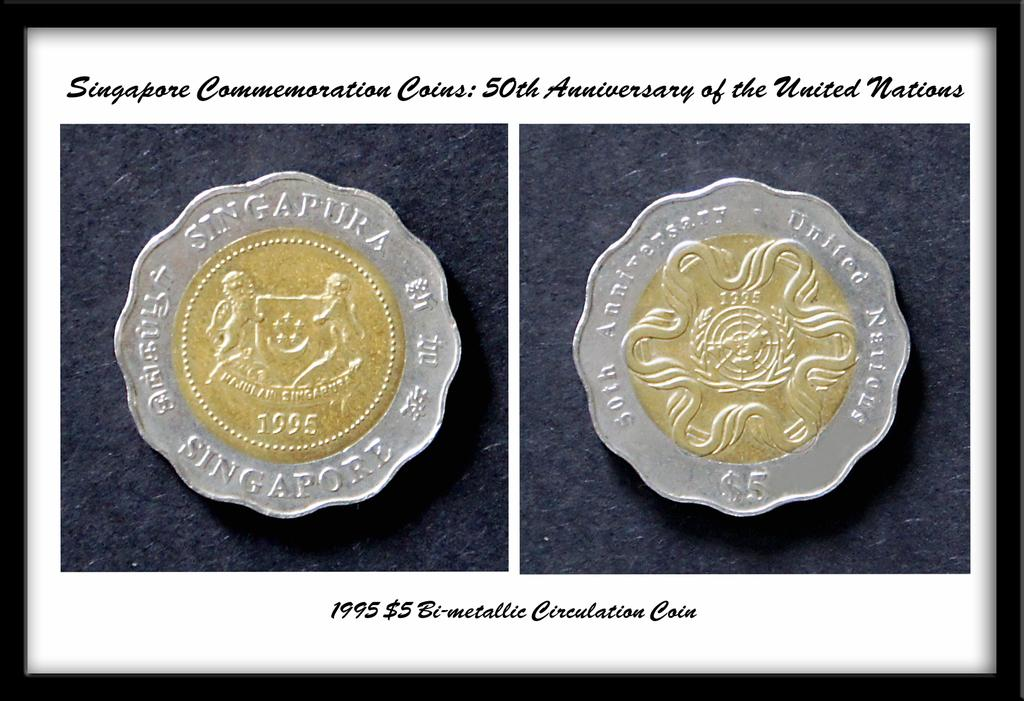<image>
Give a short and clear explanation of the subsequent image. Two framed coins commemorate the 50th anniversary of the United Nations. 